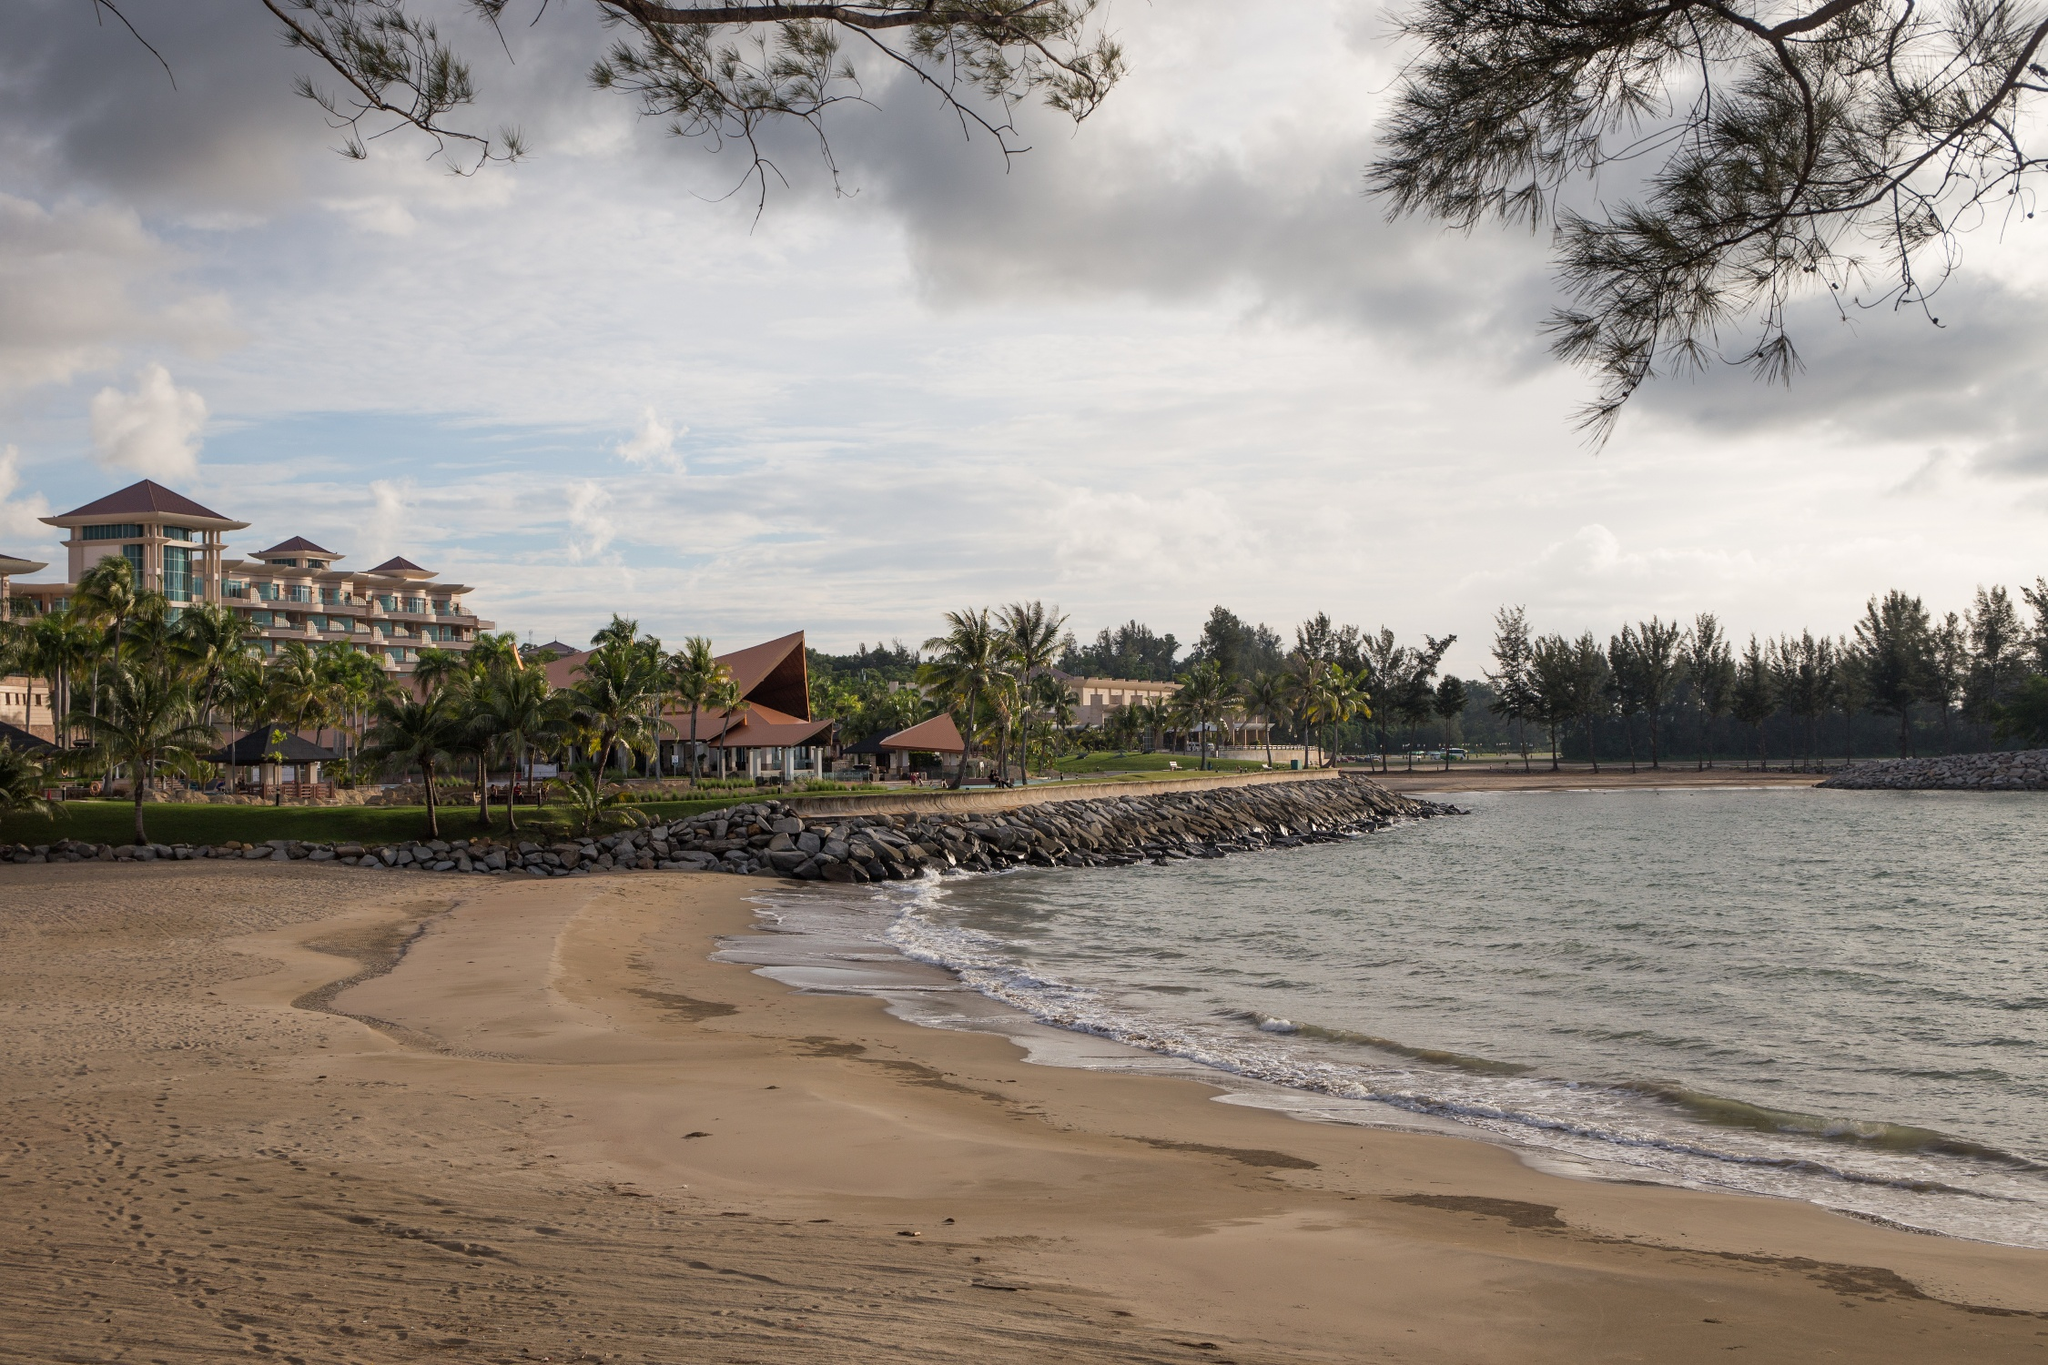Analyze the image in a comprehensive and detailed manner. This image captures a serene and picturesque coastal scene. The foreground features a sandy beach where gentle waves wash ashore. A stone barrier separates this section of the beach from the broader expanse of the sea, serving both aesthetic and functional purposes. Further back, we can see a lush array of palm trees, contributing to a tropical ambiance. Nestled among the greenery is a resort characterized by its red-tiled roofs and whitewashed walls, which stand out prominently in the landscape. The architecture of the resort buildings combines modern elements with traditional influences, providing a sense of tranquility and luxury. Above this idyllic scene, the sky is lightly overcast with clouds, adding a layer of depth and calmness. The natural framing provided by the tree branches at the top of the image complements the overall composition, enhancing the viewer's focus on this beautiful seaside getaway. Despite the landmark identifier 'sa_13664', there is no additional geographical information provided about the location of this beach resort. 